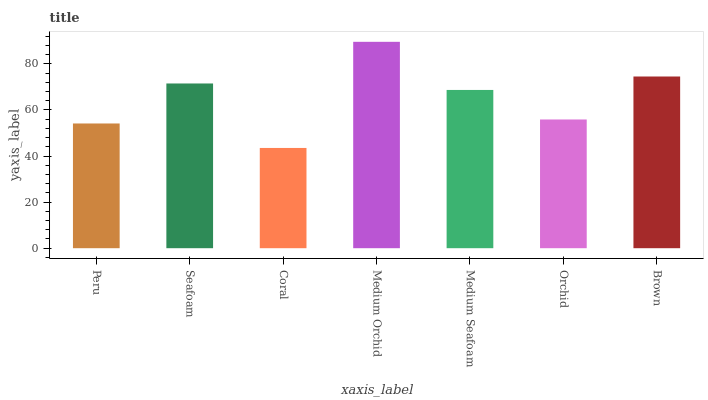Is Coral the minimum?
Answer yes or no. Yes. Is Medium Orchid the maximum?
Answer yes or no. Yes. Is Seafoam the minimum?
Answer yes or no. No. Is Seafoam the maximum?
Answer yes or no. No. Is Seafoam greater than Peru?
Answer yes or no. Yes. Is Peru less than Seafoam?
Answer yes or no. Yes. Is Peru greater than Seafoam?
Answer yes or no. No. Is Seafoam less than Peru?
Answer yes or no. No. Is Medium Seafoam the high median?
Answer yes or no. Yes. Is Medium Seafoam the low median?
Answer yes or no. Yes. Is Peru the high median?
Answer yes or no. No. Is Peru the low median?
Answer yes or no. No. 